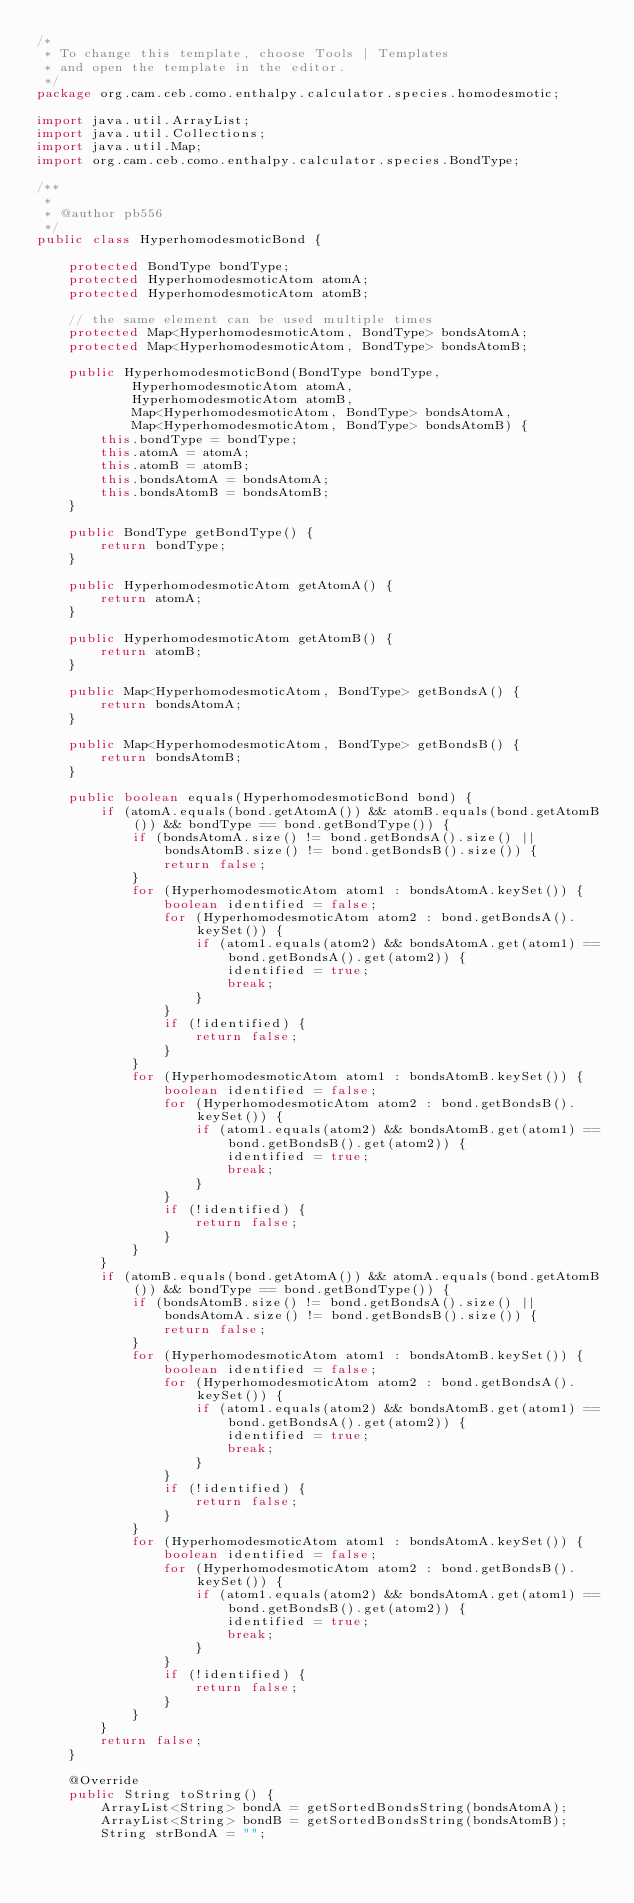<code> <loc_0><loc_0><loc_500><loc_500><_Java_>/*
 * To change this template, choose Tools | Templates
 * and open the template in the editor.
 */
package org.cam.ceb.como.enthalpy.calculator.species.homodesmotic;

import java.util.ArrayList;
import java.util.Collections;
import java.util.Map;
import org.cam.ceb.como.enthalpy.calculator.species.BondType;

/**
 *
 * @author pb556
 */
public class HyperhomodesmoticBond {
    
    protected BondType bondType;
    protected HyperhomodesmoticAtom atomA;
    protected HyperhomodesmoticAtom atomB;
    
    // the same element can be used multiple times
    protected Map<HyperhomodesmoticAtom, BondType> bondsAtomA;
    protected Map<HyperhomodesmoticAtom, BondType> bondsAtomB;

    public HyperhomodesmoticBond(BondType bondType, 
            HyperhomodesmoticAtom atomA, 
            HyperhomodesmoticAtom atomB, 
            Map<HyperhomodesmoticAtom, BondType> bondsAtomA, 
            Map<HyperhomodesmoticAtom, BondType> bondsAtomB) {
        this.bondType = bondType;
        this.atomA = atomA;
        this.atomB = atomB;
        this.bondsAtomA = bondsAtomA;
        this.bondsAtomB = bondsAtomB;
    }

    public BondType getBondType() {
        return bondType;
    }

    public HyperhomodesmoticAtom getAtomA() {
        return atomA;
    }
    
    public HyperhomodesmoticAtom getAtomB() {
        return atomB;
    }
    
    public Map<HyperhomodesmoticAtom, BondType> getBondsA() {
        return bondsAtomA;
    }
    
    public Map<HyperhomodesmoticAtom, BondType> getBondsB() {
        return bondsAtomB;
    }

    public boolean equals(HyperhomodesmoticBond bond) {
        if (atomA.equals(bond.getAtomA()) && atomB.equals(bond.getAtomB()) && bondType == bond.getBondType()) {
            if (bondsAtomA.size() != bond.getBondsA().size() || bondsAtomB.size() != bond.getBondsB().size()) {
                return false;
            }
            for (HyperhomodesmoticAtom atom1 : bondsAtomA.keySet()) {
                boolean identified = false;
                for (HyperhomodesmoticAtom atom2 : bond.getBondsA().keySet()) {
                    if (atom1.equals(atom2) && bondsAtomA.get(atom1) == bond.getBondsA().get(atom2)) {
                        identified = true;
                        break;
                    }
                }
                if (!identified) {
                    return false;
                }
            }
            for (HyperhomodesmoticAtom atom1 : bondsAtomB.keySet()) {
                boolean identified = false;
                for (HyperhomodesmoticAtom atom2 : bond.getBondsB().keySet()) {
                    if (atom1.equals(atom2) && bondsAtomB.get(atom1) == bond.getBondsB().get(atom2)) {
                        identified = true;
                        break;
                    }
                }
                if (!identified) {
                    return false;
                }
            }
        }
        if (atomB.equals(bond.getAtomA()) && atomA.equals(bond.getAtomB()) && bondType == bond.getBondType()) {
            if (bondsAtomB.size() != bond.getBondsA().size() || bondsAtomA.size() != bond.getBondsB().size()) {
                return false;
            }
            for (HyperhomodesmoticAtom atom1 : bondsAtomB.keySet()) {
                boolean identified = false;
                for (HyperhomodesmoticAtom atom2 : bond.getBondsA().keySet()) {
                    if (atom1.equals(atom2) && bondsAtomB.get(atom1) == bond.getBondsA().get(atom2)) {
                        identified = true;
                        break;
                    }
                }
                if (!identified) {
                    return false;
                }
            }
            for (HyperhomodesmoticAtom atom1 : bondsAtomA.keySet()) {
                boolean identified = false;
                for (HyperhomodesmoticAtom atom2 : bond.getBondsB().keySet()) {
                    if (atom1.equals(atom2) && bondsAtomA.get(atom1) == bond.getBondsB().get(atom2)) {
                        identified = true;
                        break;
                    }
                }
                if (!identified) {
                    return false;
                }
            }
        }
        return false;
    }
    
    @Override
    public String toString() {
        ArrayList<String> bondA = getSortedBondsString(bondsAtomA);
        ArrayList<String> bondB = getSortedBondsString(bondsAtomB);
        String strBondA = "";</code> 